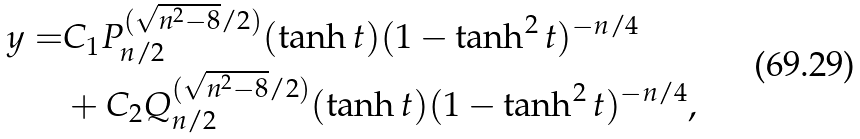Convert formula to latex. <formula><loc_0><loc_0><loc_500><loc_500>y = & C _ { 1 } P _ { n / 2 } ^ { ( \sqrt { n ^ { 2 } - 8 } / 2 ) } ( \tanh { t } ) ( 1 - \tanh ^ { 2 } { t } ) ^ { - n / 4 } \\ & + C _ { 2 } Q _ { n / 2 } ^ { ( \sqrt { n ^ { 2 } - 8 } / 2 ) } ( \tanh { t } ) ( 1 - \tanh ^ { 2 } { t } ) ^ { - n / 4 } ,</formula> 